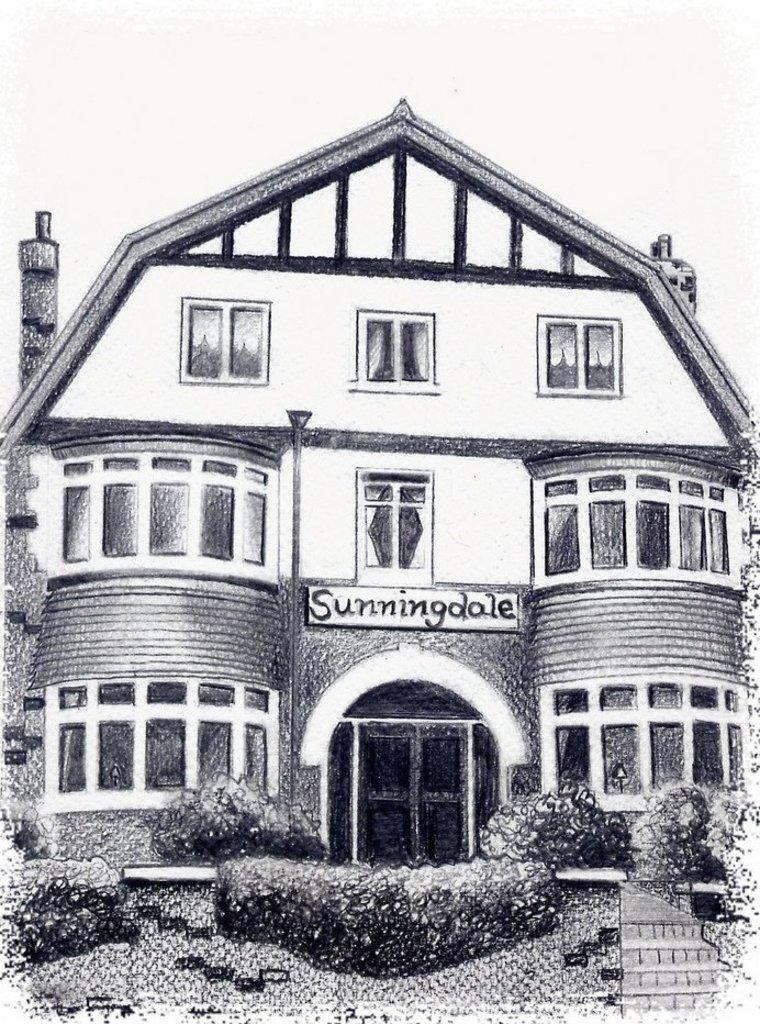What is the color scheme of the image? The image is black and white. What is the main subject of the picture? There is a depiction of an image in the picture. What type of structure can be seen in the image? There is a building in the picture. What type of vegetation is present in the image? There are bushes in the picture. What is written on the board in the picture? There is a board with a word written on it in the picture. What type of sweater is the potato wearing in the image? There is no potato or sweater present in the image. What type of pleasure can be seen in the image? There is no reference to pleasure in the image; it features a depiction of an image, a building, bushes, and a board with a word written on it. 